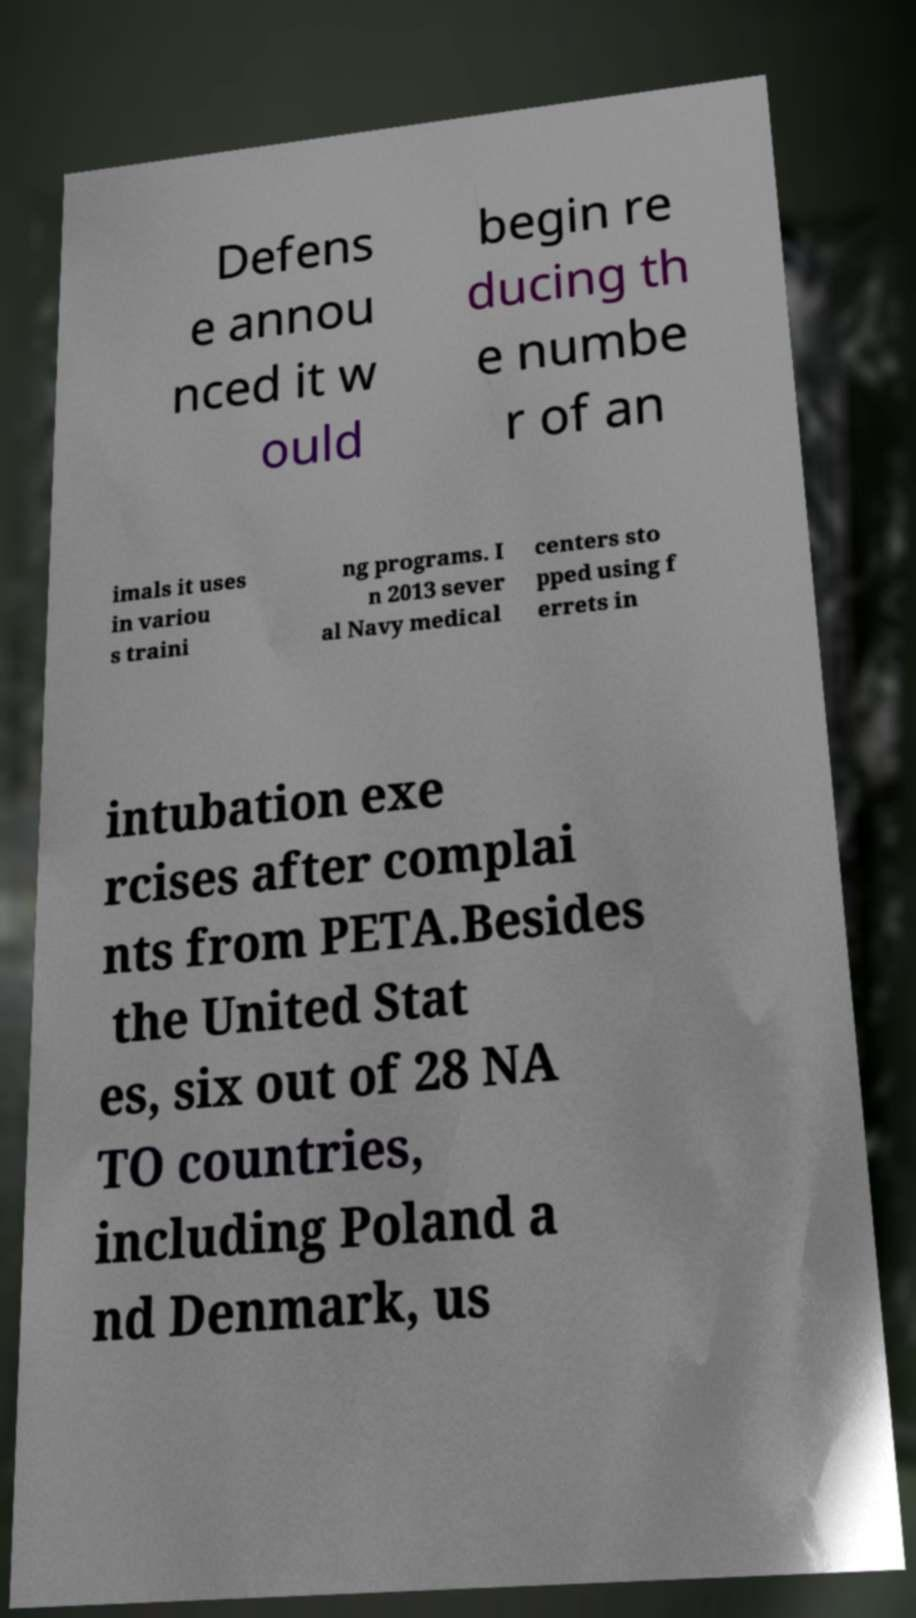Could you assist in decoding the text presented in this image and type it out clearly? Defens e annou nced it w ould begin re ducing th e numbe r of an imals it uses in variou s traini ng programs. I n 2013 sever al Navy medical centers sto pped using f errets in intubation exe rcises after complai nts from PETA.Besides the United Stat es, six out of 28 NA TO countries, including Poland a nd Denmark, us 